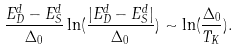<formula> <loc_0><loc_0><loc_500><loc_500>\frac { E _ { D } ^ { d } - E _ { S } ^ { d } } { \Delta _ { 0 } } \ln ( \frac { | E _ { D } ^ { d } - E _ { S } ^ { d } | } { \Delta _ { 0 } } ) \sim \ln ( \frac { \Delta _ { 0 } } { T _ { K } } ) .</formula> 